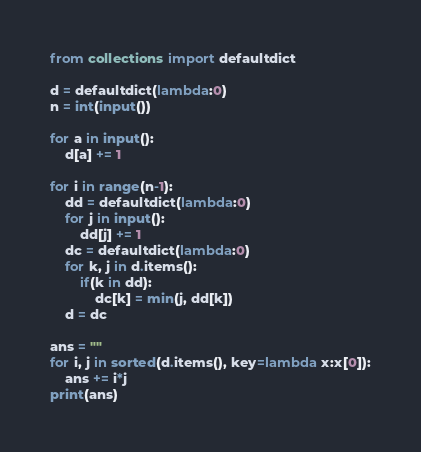Convert code to text. <code><loc_0><loc_0><loc_500><loc_500><_Python_>from collections import defaultdict

d = defaultdict(lambda:0)
n = int(input())

for a in input():
    d[a] += 1

for i in range(n-1):
    dd = defaultdict(lambda:0)
    for j in input():
        dd[j] += 1
    dc = defaultdict(lambda:0)
    for k, j in d.items():
        if(k in dd):
            dc[k] = min(j, dd[k])
    d = dc

ans = ""
for i, j in sorted(d.items(), key=lambda x:x[0]):
    ans += i*j
print(ans)</code> 